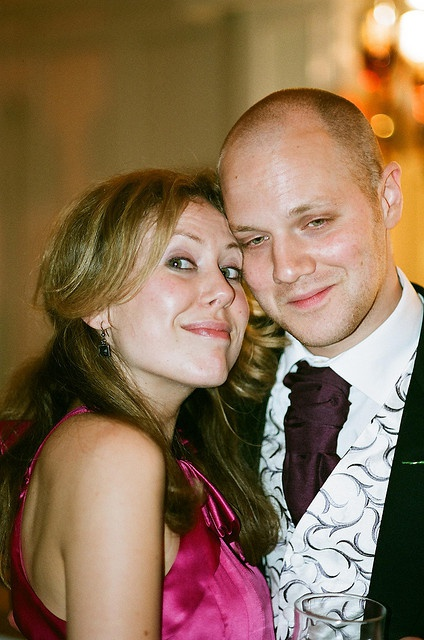Describe the objects in this image and their specific colors. I can see people in maroon, black, lightgray, and tan tones, people in maroon, black, tan, and olive tones, tie in maroon, black, lightgray, and purple tones, wine glass in maroon, lightgray, black, darkgray, and gray tones, and cup in maroon, lightgray, darkgray, black, and gray tones in this image. 